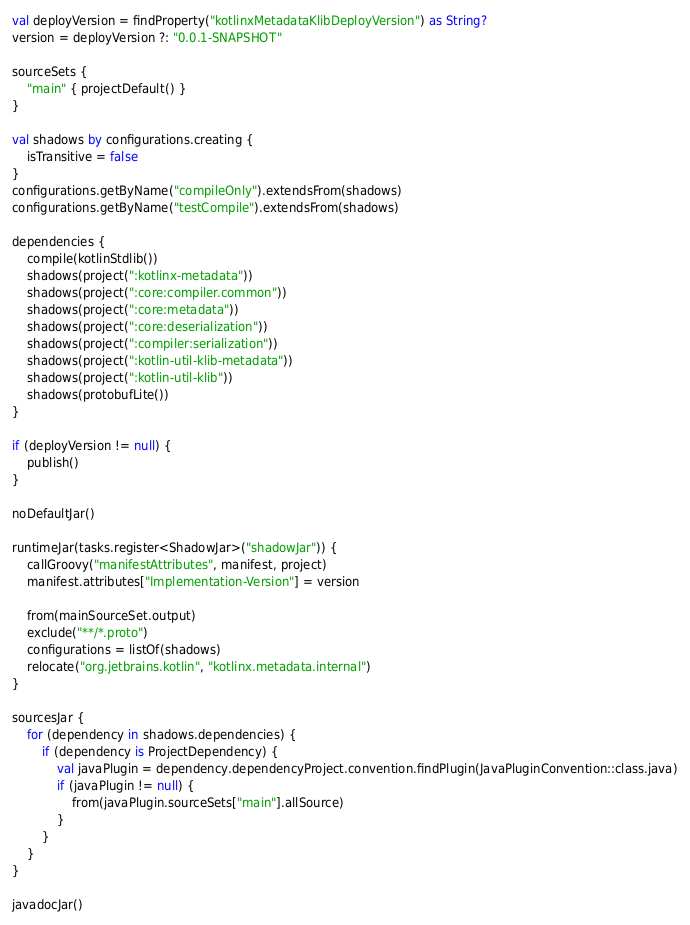Convert code to text. <code><loc_0><loc_0><loc_500><loc_500><_Kotlin_>val deployVersion = findProperty("kotlinxMetadataKlibDeployVersion") as String?
version = deployVersion ?: "0.0.1-SNAPSHOT"

sourceSets {
    "main" { projectDefault() }
}

val shadows by configurations.creating {
    isTransitive = false
}
configurations.getByName("compileOnly").extendsFrom(shadows)
configurations.getByName("testCompile").extendsFrom(shadows)

dependencies {
    compile(kotlinStdlib())
    shadows(project(":kotlinx-metadata"))
    shadows(project(":core:compiler.common"))
    shadows(project(":core:metadata"))
    shadows(project(":core:deserialization"))
    shadows(project(":compiler:serialization"))
    shadows(project(":kotlin-util-klib-metadata"))
    shadows(project(":kotlin-util-klib"))
    shadows(protobufLite())
}

if (deployVersion != null) {
    publish()
}

noDefaultJar()

runtimeJar(tasks.register<ShadowJar>("shadowJar")) {
    callGroovy("manifestAttributes", manifest, project)
    manifest.attributes["Implementation-Version"] = version

    from(mainSourceSet.output)
    exclude("**/*.proto")
    configurations = listOf(shadows)
    relocate("org.jetbrains.kotlin", "kotlinx.metadata.internal")
}

sourcesJar {
    for (dependency in shadows.dependencies) {
        if (dependency is ProjectDependency) {
            val javaPlugin = dependency.dependencyProject.convention.findPlugin(JavaPluginConvention::class.java)
            if (javaPlugin != null) {
                from(javaPlugin.sourceSets["main"].allSource)
            }
        }
    }
}

javadocJar()
</code> 